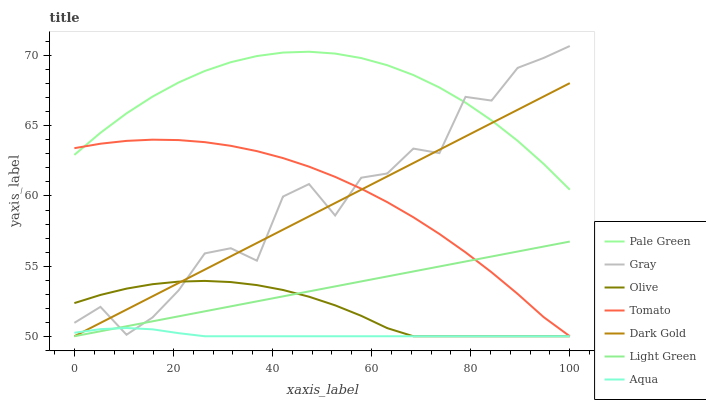Does Aqua have the minimum area under the curve?
Answer yes or no. Yes. Does Pale Green have the maximum area under the curve?
Answer yes or no. Yes. Does Gray have the minimum area under the curve?
Answer yes or no. No. Does Gray have the maximum area under the curve?
Answer yes or no. No. Is Dark Gold the smoothest?
Answer yes or no. Yes. Is Gray the roughest?
Answer yes or no. Yes. Is Gray the smoothest?
Answer yes or no. No. Is Dark Gold the roughest?
Answer yes or no. No. Does Tomato have the lowest value?
Answer yes or no. Yes. Does Gray have the lowest value?
Answer yes or no. No. Does Gray have the highest value?
Answer yes or no. Yes. Does Dark Gold have the highest value?
Answer yes or no. No. Is Light Green less than Pale Green?
Answer yes or no. Yes. Is Pale Green greater than Olive?
Answer yes or no. Yes. Does Dark Gold intersect Light Green?
Answer yes or no. Yes. Is Dark Gold less than Light Green?
Answer yes or no. No. Is Dark Gold greater than Light Green?
Answer yes or no. No. Does Light Green intersect Pale Green?
Answer yes or no. No. 